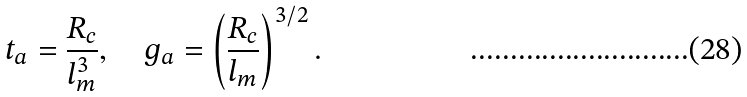<formula> <loc_0><loc_0><loc_500><loc_500>t _ { a } = { \frac { R _ { c } } { l _ { m } ^ { 3 } } } , \quad g _ { a } = \left ( { \frac { R _ { c } } { l _ { m } } } \right ) ^ { 3 / 2 } .</formula> 